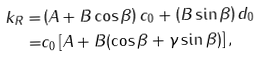<formula> <loc_0><loc_0><loc_500><loc_500>k _ { R } = & \left ( A + B \cos \beta \right ) c _ { 0 } + \left ( B \sin \beta \right ) d _ { 0 } \\ = & c _ { 0 } \left [ A + B ( \cos \beta + \gamma \sin \beta ) \right ] ,</formula> 